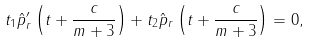Convert formula to latex. <formula><loc_0><loc_0><loc_500><loc_500>t _ { 1 } \hat { p } _ { r } ^ { \prime } \left ( t + \frac { c } { m + 3 } \right ) + t _ { 2 } \hat { p } _ { r } \left ( t + \frac { c } { m + 3 } \right ) = 0 ,</formula> 